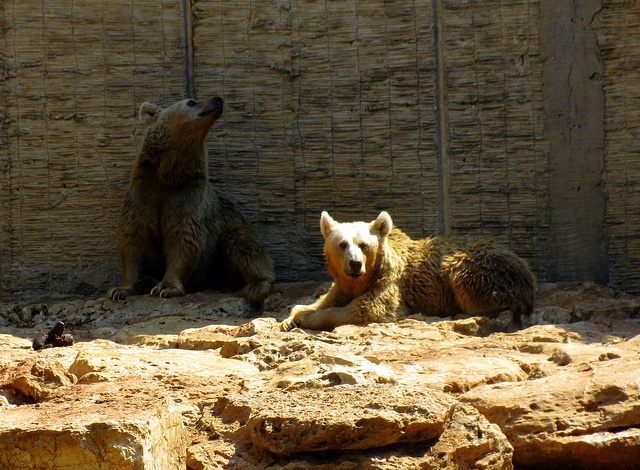Describe the objects in this image and their specific colors. I can see bear in black and gray tones and bear in black, maroon, olive, and ivory tones in this image. 